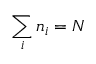<formula> <loc_0><loc_0><loc_500><loc_500>{ \sum _ { i } n _ { i } = N }</formula> 